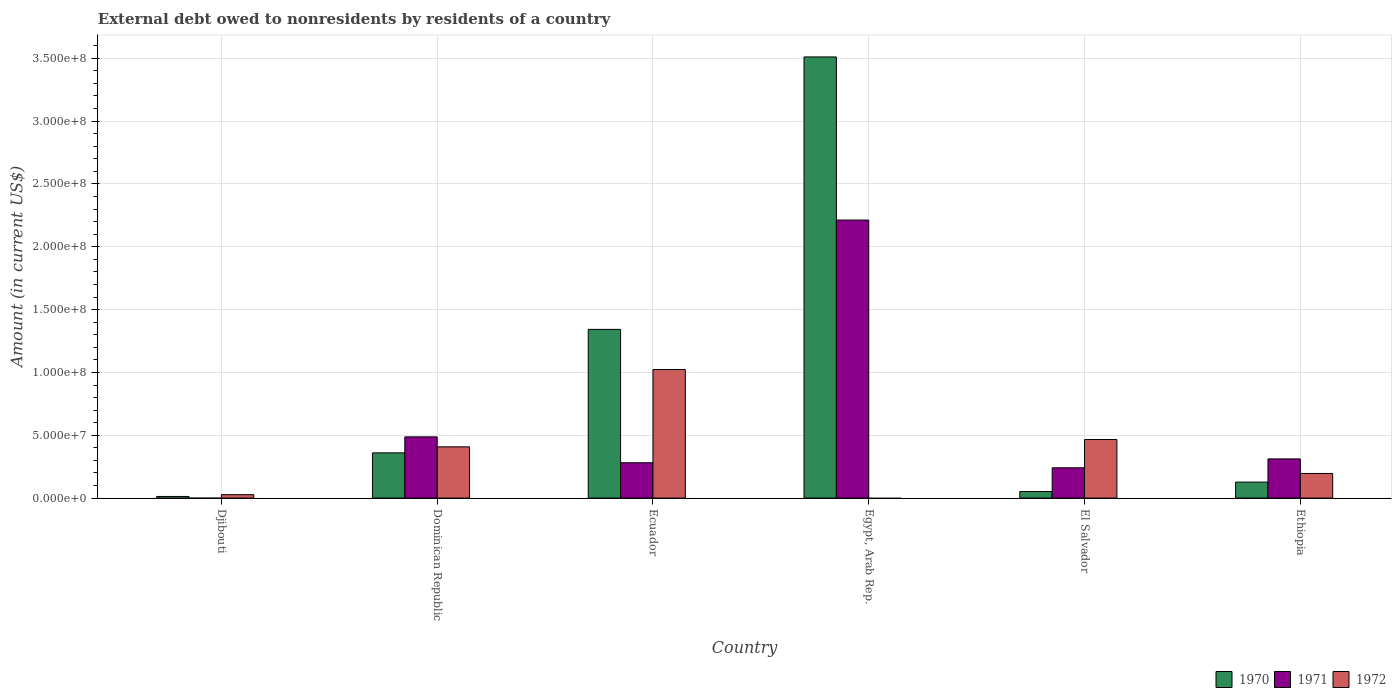How many groups of bars are there?
Keep it short and to the point. 6. Are the number of bars per tick equal to the number of legend labels?
Offer a terse response. No. How many bars are there on the 4th tick from the left?
Offer a terse response. 2. What is the label of the 5th group of bars from the left?
Your answer should be very brief. El Salvador. In how many cases, is the number of bars for a given country not equal to the number of legend labels?
Ensure brevity in your answer.  2. What is the external debt owed by residents in 1970 in Ethiopia?
Your answer should be very brief. 1.27e+07. Across all countries, what is the maximum external debt owed by residents in 1971?
Your response must be concise. 2.21e+08. Across all countries, what is the minimum external debt owed by residents in 1972?
Your answer should be very brief. 0. In which country was the external debt owed by residents in 1972 maximum?
Provide a short and direct response. Ecuador. What is the total external debt owed by residents in 1972 in the graph?
Keep it short and to the point. 2.12e+08. What is the difference between the external debt owed by residents in 1971 in Ecuador and that in Egypt, Arab Rep.?
Provide a short and direct response. -1.93e+08. What is the difference between the external debt owed by residents in 1971 in Egypt, Arab Rep. and the external debt owed by residents in 1972 in Ethiopia?
Give a very brief answer. 2.02e+08. What is the average external debt owed by residents in 1971 per country?
Ensure brevity in your answer.  5.89e+07. What is the difference between the external debt owed by residents of/in 1972 and external debt owed by residents of/in 1970 in Ecuador?
Offer a terse response. -3.19e+07. In how many countries, is the external debt owed by residents in 1971 greater than 330000000 US$?
Your answer should be very brief. 0. What is the ratio of the external debt owed by residents in 1970 in Dominican Republic to that in Egypt, Arab Rep.?
Keep it short and to the point. 0.1. What is the difference between the highest and the second highest external debt owed by residents in 1972?
Provide a succinct answer. 5.57e+07. What is the difference between the highest and the lowest external debt owed by residents in 1972?
Provide a short and direct response. 1.02e+08. In how many countries, is the external debt owed by residents in 1972 greater than the average external debt owed by residents in 1972 taken over all countries?
Your response must be concise. 3. How many bars are there?
Make the answer very short. 16. What is the difference between two consecutive major ticks on the Y-axis?
Keep it short and to the point. 5.00e+07. Does the graph contain grids?
Your answer should be very brief. Yes. What is the title of the graph?
Keep it short and to the point. External debt owed to nonresidents by residents of a country. What is the Amount (in current US$) in 1970 in Djibouti?
Offer a terse response. 1.30e+06. What is the Amount (in current US$) in 1972 in Djibouti?
Your response must be concise. 2.72e+06. What is the Amount (in current US$) in 1970 in Dominican Republic?
Make the answer very short. 3.60e+07. What is the Amount (in current US$) in 1971 in Dominican Republic?
Provide a succinct answer. 4.87e+07. What is the Amount (in current US$) of 1972 in Dominican Republic?
Offer a very short reply. 4.08e+07. What is the Amount (in current US$) of 1970 in Ecuador?
Provide a succinct answer. 1.34e+08. What is the Amount (in current US$) in 1971 in Ecuador?
Your answer should be very brief. 2.81e+07. What is the Amount (in current US$) in 1972 in Ecuador?
Offer a terse response. 1.02e+08. What is the Amount (in current US$) of 1970 in Egypt, Arab Rep.?
Give a very brief answer. 3.51e+08. What is the Amount (in current US$) in 1971 in Egypt, Arab Rep.?
Provide a short and direct response. 2.21e+08. What is the Amount (in current US$) in 1970 in El Salvador?
Make the answer very short. 5.25e+06. What is the Amount (in current US$) of 1971 in El Salvador?
Offer a terse response. 2.41e+07. What is the Amount (in current US$) of 1972 in El Salvador?
Provide a succinct answer. 4.66e+07. What is the Amount (in current US$) in 1970 in Ethiopia?
Offer a terse response. 1.27e+07. What is the Amount (in current US$) in 1971 in Ethiopia?
Provide a short and direct response. 3.12e+07. What is the Amount (in current US$) of 1972 in Ethiopia?
Give a very brief answer. 1.96e+07. Across all countries, what is the maximum Amount (in current US$) in 1970?
Your answer should be very brief. 3.51e+08. Across all countries, what is the maximum Amount (in current US$) in 1971?
Your answer should be very brief. 2.21e+08. Across all countries, what is the maximum Amount (in current US$) of 1972?
Give a very brief answer. 1.02e+08. Across all countries, what is the minimum Amount (in current US$) of 1970?
Provide a succinct answer. 1.30e+06. Across all countries, what is the minimum Amount (in current US$) of 1972?
Ensure brevity in your answer.  0. What is the total Amount (in current US$) in 1970 in the graph?
Ensure brevity in your answer.  5.41e+08. What is the total Amount (in current US$) of 1971 in the graph?
Your answer should be compact. 3.53e+08. What is the total Amount (in current US$) in 1972 in the graph?
Your answer should be compact. 2.12e+08. What is the difference between the Amount (in current US$) of 1970 in Djibouti and that in Dominican Republic?
Keep it short and to the point. -3.47e+07. What is the difference between the Amount (in current US$) of 1972 in Djibouti and that in Dominican Republic?
Provide a succinct answer. -3.81e+07. What is the difference between the Amount (in current US$) of 1970 in Djibouti and that in Ecuador?
Ensure brevity in your answer.  -1.33e+08. What is the difference between the Amount (in current US$) of 1972 in Djibouti and that in Ecuador?
Give a very brief answer. -9.96e+07. What is the difference between the Amount (in current US$) of 1970 in Djibouti and that in Egypt, Arab Rep.?
Keep it short and to the point. -3.50e+08. What is the difference between the Amount (in current US$) of 1970 in Djibouti and that in El Salvador?
Give a very brief answer. -3.95e+06. What is the difference between the Amount (in current US$) in 1972 in Djibouti and that in El Salvador?
Offer a very short reply. -4.39e+07. What is the difference between the Amount (in current US$) of 1970 in Djibouti and that in Ethiopia?
Keep it short and to the point. -1.14e+07. What is the difference between the Amount (in current US$) of 1972 in Djibouti and that in Ethiopia?
Your answer should be very brief. -1.69e+07. What is the difference between the Amount (in current US$) in 1970 in Dominican Republic and that in Ecuador?
Offer a very short reply. -9.83e+07. What is the difference between the Amount (in current US$) in 1971 in Dominican Republic and that in Ecuador?
Provide a short and direct response. 2.06e+07. What is the difference between the Amount (in current US$) in 1972 in Dominican Republic and that in Ecuador?
Offer a very short reply. -6.15e+07. What is the difference between the Amount (in current US$) of 1970 in Dominican Republic and that in Egypt, Arab Rep.?
Your response must be concise. -3.15e+08. What is the difference between the Amount (in current US$) of 1971 in Dominican Republic and that in Egypt, Arab Rep.?
Your response must be concise. -1.73e+08. What is the difference between the Amount (in current US$) in 1970 in Dominican Republic and that in El Salvador?
Your answer should be very brief. 3.07e+07. What is the difference between the Amount (in current US$) of 1971 in Dominican Republic and that in El Salvador?
Provide a succinct answer. 2.46e+07. What is the difference between the Amount (in current US$) in 1972 in Dominican Republic and that in El Salvador?
Give a very brief answer. -5.82e+06. What is the difference between the Amount (in current US$) in 1970 in Dominican Republic and that in Ethiopia?
Your response must be concise. 2.33e+07. What is the difference between the Amount (in current US$) in 1971 in Dominican Republic and that in Ethiopia?
Your answer should be compact. 1.75e+07. What is the difference between the Amount (in current US$) of 1972 in Dominican Republic and that in Ethiopia?
Your response must be concise. 2.12e+07. What is the difference between the Amount (in current US$) in 1970 in Ecuador and that in Egypt, Arab Rep.?
Provide a short and direct response. -2.17e+08. What is the difference between the Amount (in current US$) in 1971 in Ecuador and that in Egypt, Arab Rep.?
Your answer should be compact. -1.93e+08. What is the difference between the Amount (in current US$) in 1970 in Ecuador and that in El Salvador?
Provide a short and direct response. 1.29e+08. What is the difference between the Amount (in current US$) in 1971 in Ecuador and that in El Salvador?
Give a very brief answer. 4.01e+06. What is the difference between the Amount (in current US$) in 1972 in Ecuador and that in El Salvador?
Ensure brevity in your answer.  5.57e+07. What is the difference between the Amount (in current US$) of 1970 in Ecuador and that in Ethiopia?
Keep it short and to the point. 1.22e+08. What is the difference between the Amount (in current US$) of 1971 in Ecuador and that in Ethiopia?
Your answer should be compact. -3.06e+06. What is the difference between the Amount (in current US$) of 1972 in Ecuador and that in Ethiopia?
Ensure brevity in your answer.  8.27e+07. What is the difference between the Amount (in current US$) in 1970 in Egypt, Arab Rep. and that in El Salvador?
Ensure brevity in your answer.  3.46e+08. What is the difference between the Amount (in current US$) of 1971 in Egypt, Arab Rep. and that in El Salvador?
Keep it short and to the point. 1.97e+08. What is the difference between the Amount (in current US$) of 1970 in Egypt, Arab Rep. and that in Ethiopia?
Give a very brief answer. 3.38e+08. What is the difference between the Amount (in current US$) of 1971 in Egypt, Arab Rep. and that in Ethiopia?
Your answer should be very brief. 1.90e+08. What is the difference between the Amount (in current US$) of 1970 in El Salvador and that in Ethiopia?
Offer a very short reply. -7.48e+06. What is the difference between the Amount (in current US$) of 1971 in El Salvador and that in Ethiopia?
Your response must be concise. -7.07e+06. What is the difference between the Amount (in current US$) in 1972 in El Salvador and that in Ethiopia?
Your response must be concise. 2.70e+07. What is the difference between the Amount (in current US$) in 1970 in Djibouti and the Amount (in current US$) in 1971 in Dominican Republic?
Your answer should be compact. -4.74e+07. What is the difference between the Amount (in current US$) in 1970 in Djibouti and the Amount (in current US$) in 1972 in Dominican Republic?
Ensure brevity in your answer.  -3.95e+07. What is the difference between the Amount (in current US$) of 1970 in Djibouti and the Amount (in current US$) of 1971 in Ecuador?
Make the answer very short. -2.68e+07. What is the difference between the Amount (in current US$) of 1970 in Djibouti and the Amount (in current US$) of 1972 in Ecuador?
Give a very brief answer. -1.01e+08. What is the difference between the Amount (in current US$) in 1970 in Djibouti and the Amount (in current US$) in 1971 in Egypt, Arab Rep.?
Your answer should be very brief. -2.20e+08. What is the difference between the Amount (in current US$) of 1970 in Djibouti and the Amount (in current US$) of 1971 in El Salvador?
Your answer should be very brief. -2.28e+07. What is the difference between the Amount (in current US$) of 1970 in Djibouti and the Amount (in current US$) of 1972 in El Salvador?
Provide a short and direct response. -4.53e+07. What is the difference between the Amount (in current US$) in 1970 in Djibouti and the Amount (in current US$) in 1971 in Ethiopia?
Ensure brevity in your answer.  -2.99e+07. What is the difference between the Amount (in current US$) of 1970 in Djibouti and the Amount (in current US$) of 1972 in Ethiopia?
Offer a very short reply. -1.83e+07. What is the difference between the Amount (in current US$) of 1970 in Dominican Republic and the Amount (in current US$) of 1971 in Ecuador?
Provide a succinct answer. 7.88e+06. What is the difference between the Amount (in current US$) in 1970 in Dominican Republic and the Amount (in current US$) in 1972 in Ecuador?
Give a very brief answer. -6.63e+07. What is the difference between the Amount (in current US$) in 1971 in Dominican Republic and the Amount (in current US$) in 1972 in Ecuador?
Your response must be concise. -5.36e+07. What is the difference between the Amount (in current US$) in 1970 in Dominican Republic and the Amount (in current US$) in 1971 in Egypt, Arab Rep.?
Give a very brief answer. -1.85e+08. What is the difference between the Amount (in current US$) in 1970 in Dominican Republic and the Amount (in current US$) in 1971 in El Salvador?
Keep it short and to the point. 1.19e+07. What is the difference between the Amount (in current US$) of 1970 in Dominican Republic and the Amount (in current US$) of 1972 in El Salvador?
Offer a terse response. -1.06e+07. What is the difference between the Amount (in current US$) in 1971 in Dominican Republic and the Amount (in current US$) in 1972 in El Salvador?
Make the answer very short. 2.10e+06. What is the difference between the Amount (in current US$) in 1970 in Dominican Republic and the Amount (in current US$) in 1971 in Ethiopia?
Provide a short and direct response. 4.81e+06. What is the difference between the Amount (in current US$) in 1970 in Dominican Republic and the Amount (in current US$) in 1972 in Ethiopia?
Your answer should be very brief. 1.64e+07. What is the difference between the Amount (in current US$) in 1971 in Dominican Republic and the Amount (in current US$) in 1972 in Ethiopia?
Offer a very short reply. 2.91e+07. What is the difference between the Amount (in current US$) in 1970 in Ecuador and the Amount (in current US$) in 1971 in Egypt, Arab Rep.?
Provide a short and direct response. -8.70e+07. What is the difference between the Amount (in current US$) of 1970 in Ecuador and the Amount (in current US$) of 1971 in El Salvador?
Provide a short and direct response. 1.10e+08. What is the difference between the Amount (in current US$) in 1970 in Ecuador and the Amount (in current US$) in 1972 in El Salvador?
Make the answer very short. 8.76e+07. What is the difference between the Amount (in current US$) in 1971 in Ecuador and the Amount (in current US$) in 1972 in El Salvador?
Your answer should be very brief. -1.85e+07. What is the difference between the Amount (in current US$) of 1970 in Ecuador and the Amount (in current US$) of 1971 in Ethiopia?
Offer a terse response. 1.03e+08. What is the difference between the Amount (in current US$) of 1970 in Ecuador and the Amount (in current US$) of 1972 in Ethiopia?
Offer a terse response. 1.15e+08. What is the difference between the Amount (in current US$) of 1971 in Ecuador and the Amount (in current US$) of 1972 in Ethiopia?
Provide a short and direct response. 8.52e+06. What is the difference between the Amount (in current US$) of 1970 in Egypt, Arab Rep. and the Amount (in current US$) of 1971 in El Salvador?
Offer a terse response. 3.27e+08. What is the difference between the Amount (in current US$) of 1970 in Egypt, Arab Rep. and the Amount (in current US$) of 1972 in El Salvador?
Your answer should be compact. 3.04e+08. What is the difference between the Amount (in current US$) of 1971 in Egypt, Arab Rep. and the Amount (in current US$) of 1972 in El Salvador?
Ensure brevity in your answer.  1.75e+08. What is the difference between the Amount (in current US$) in 1970 in Egypt, Arab Rep. and the Amount (in current US$) in 1971 in Ethiopia?
Offer a very short reply. 3.20e+08. What is the difference between the Amount (in current US$) of 1970 in Egypt, Arab Rep. and the Amount (in current US$) of 1972 in Ethiopia?
Offer a terse response. 3.31e+08. What is the difference between the Amount (in current US$) in 1971 in Egypt, Arab Rep. and the Amount (in current US$) in 1972 in Ethiopia?
Keep it short and to the point. 2.02e+08. What is the difference between the Amount (in current US$) of 1970 in El Salvador and the Amount (in current US$) of 1971 in Ethiopia?
Make the answer very short. -2.59e+07. What is the difference between the Amount (in current US$) in 1970 in El Salvador and the Amount (in current US$) in 1972 in Ethiopia?
Provide a succinct answer. -1.44e+07. What is the difference between the Amount (in current US$) of 1971 in El Salvador and the Amount (in current US$) of 1972 in Ethiopia?
Give a very brief answer. 4.50e+06. What is the average Amount (in current US$) of 1970 per country?
Your response must be concise. 9.01e+07. What is the average Amount (in current US$) in 1971 per country?
Ensure brevity in your answer.  5.89e+07. What is the average Amount (in current US$) of 1972 per country?
Keep it short and to the point. 3.53e+07. What is the difference between the Amount (in current US$) in 1970 and Amount (in current US$) in 1972 in Djibouti?
Your answer should be very brief. -1.42e+06. What is the difference between the Amount (in current US$) in 1970 and Amount (in current US$) in 1971 in Dominican Republic?
Your answer should be compact. -1.27e+07. What is the difference between the Amount (in current US$) in 1970 and Amount (in current US$) in 1972 in Dominican Republic?
Your answer should be very brief. -4.81e+06. What is the difference between the Amount (in current US$) in 1971 and Amount (in current US$) in 1972 in Dominican Republic?
Your answer should be very brief. 7.91e+06. What is the difference between the Amount (in current US$) of 1970 and Amount (in current US$) of 1971 in Ecuador?
Keep it short and to the point. 1.06e+08. What is the difference between the Amount (in current US$) of 1970 and Amount (in current US$) of 1972 in Ecuador?
Ensure brevity in your answer.  3.19e+07. What is the difference between the Amount (in current US$) of 1971 and Amount (in current US$) of 1972 in Ecuador?
Give a very brief answer. -7.42e+07. What is the difference between the Amount (in current US$) of 1970 and Amount (in current US$) of 1971 in Egypt, Arab Rep.?
Ensure brevity in your answer.  1.30e+08. What is the difference between the Amount (in current US$) in 1970 and Amount (in current US$) in 1971 in El Salvador?
Provide a short and direct response. -1.89e+07. What is the difference between the Amount (in current US$) in 1970 and Amount (in current US$) in 1972 in El Salvador?
Your answer should be very brief. -4.14e+07. What is the difference between the Amount (in current US$) of 1971 and Amount (in current US$) of 1972 in El Salvador?
Give a very brief answer. -2.25e+07. What is the difference between the Amount (in current US$) in 1970 and Amount (in current US$) in 1971 in Ethiopia?
Provide a succinct answer. -1.84e+07. What is the difference between the Amount (in current US$) of 1970 and Amount (in current US$) of 1972 in Ethiopia?
Provide a succinct answer. -6.87e+06. What is the difference between the Amount (in current US$) in 1971 and Amount (in current US$) in 1972 in Ethiopia?
Your answer should be compact. 1.16e+07. What is the ratio of the Amount (in current US$) of 1970 in Djibouti to that in Dominican Republic?
Provide a succinct answer. 0.04. What is the ratio of the Amount (in current US$) of 1972 in Djibouti to that in Dominican Republic?
Offer a very short reply. 0.07. What is the ratio of the Amount (in current US$) of 1970 in Djibouti to that in Ecuador?
Give a very brief answer. 0.01. What is the ratio of the Amount (in current US$) in 1972 in Djibouti to that in Ecuador?
Ensure brevity in your answer.  0.03. What is the ratio of the Amount (in current US$) in 1970 in Djibouti to that in Egypt, Arab Rep.?
Your answer should be compact. 0. What is the ratio of the Amount (in current US$) of 1970 in Djibouti to that in El Salvador?
Offer a terse response. 0.25. What is the ratio of the Amount (in current US$) of 1972 in Djibouti to that in El Salvador?
Provide a succinct answer. 0.06. What is the ratio of the Amount (in current US$) in 1970 in Djibouti to that in Ethiopia?
Your response must be concise. 0.1. What is the ratio of the Amount (in current US$) of 1972 in Djibouti to that in Ethiopia?
Ensure brevity in your answer.  0.14. What is the ratio of the Amount (in current US$) in 1970 in Dominican Republic to that in Ecuador?
Your answer should be compact. 0.27. What is the ratio of the Amount (in current US$) of 1971 in Dominican Republic to that in Ecuador?
Keep it short and to the point. 1.73. What is the ratio of the Amount (in current US$) of 1972 in Dominican Republic to that in Ecuador?
Your answer should be very brief. 0.4. What is the ratio of the Amount (in current US$) of 1970 in Dominican Republic to that in Egypt, Arab Rep.?
Your answer should be very brief. 0.1. What is the ratio of the Amount (in current US$) in 1971 in Dominican Republic to that in Egypt, Arab Rep.?
Keep it short and to the point. 0.22. What is the ratio of the Amount (in current US$) in 1970 in Dominican Republic to that in El Salvador?
Give a very brief answer. 6.86. What is the ratio of the Amount (in current US$) of 1971 in Dominican Republic to that in El Salvador?
Keep it short and to the point. 2.02. What is the ratio of the Amount (in current US$) of 1972 in Dominican Republic to that in El Salvador?
Keep it short and to the point. 0.88. What is the ratio of the Amount (in current US$) in 1970 in Dominican Republic to that in Ethiopia?
Offer a terse response. 2.83. What is the ratio of the Amount (in current US$) in 1971 in Dominican Republic to that in Ethiopia?
Your answer should be very brief. 1.56. What is the ratio of the Amount (in current US$) in 1972 in Dominican Republic to that in Ethiopia?
Keep it short and to the point. 2.08. What is the ratio of the Amount (in current US$) in 1970 in Ecuador to that in Egypt, Arab Rep.?
Your answer should be compact. 0.38. What is the ratio of the Amount (in current US$) of 1971 in Ecuador to that in Egypt, Arab Rep.?
Offer a terse response. 0.13. What is the ratio of the Amount (in current US$) in 1970 in Ecuador to that in El Salvador?
Your response must be concise. 25.59. What is the ratio of the Amount (in current US$) of 1971 in Ecuador to that in El Salvador?
Provide a succinct answer. 1.17. What is the ratio of the Amount (in current US$) of 1972 in Ecuador to that in El Salvador?
Offer a very short reply. 2.2. What is the ratio of the Amount (in current US$) of 1970 in Ecuador to that in Ethiopia?
Keep it short and to the point. 10.55. What is the ratio of the Amount (in current US$) of 1971 in Ecuador to that in Ethiopia?
Provide a short and direct response. 0.9. What is the ratio of the Amount (in current US$) of 1972 in Ecuador to that in Ethiopia?
Keep it short and to the point. 5.22. What is the ratio of the Amount (in current US$) in 1970 in Egypt, Arab Rep. to that in El Salvador?
Offer a terse response. 66.92. What is the ratio of the Amount (in current US$) in 1971 in Egypt, Arab Rep. to that in El Salvador?
Offer a very short reply. 9.18. What is the ratio of the Amount (in current US$) of 1970 in Egypt, Arab Rep. to that in Ethiopia?
Provide a short and direct response. 27.59. What is the ratio of the Amount (in current US$) in 1971 in Egypt, Arab Rep. to that in Ethiopia?
Your answer should be compact. 7.1. What is the ratio of the Amount (in current US$) of 1970 in El Salvador to that in Ethiopia?
Ensure brevity in your answer.  0.41. What is the ratio of the Amount (in current US$) of 1971 in El Salvador to that in Ethiopia?
Provide a succinct answer. 0.77. What is the ratio of the Amount (in current US$) of 1972 in El Salvador to that in Ethiopia?
Make the answer very short. 2.38. What is the difference between the highest and the second highest Amount (in current US$) in 1970?
Your response must be concise. 2.17e+08. What is the difference between the highest and the second highest Amount (in current US$) in 1971?
Make the answer very short. 1.73e+08. What is the difference between the highest and the second highest Amount (in current US$) of 1972?
Ensure brevity in your answer.  5.57e+07. What is the difference between the highest and the lowest Amount (in current US$) in 1970?
Give a very brief answer. 3.50e+08. What is the difference between the highest and the lowest Amount (in current US$) in 1971?
Your response must be concise. 2.21e+08. What is the difference between the highest and the lowest Amount (in current US$) in 1972?
Keep it short and to the point. 1.02e+08. 